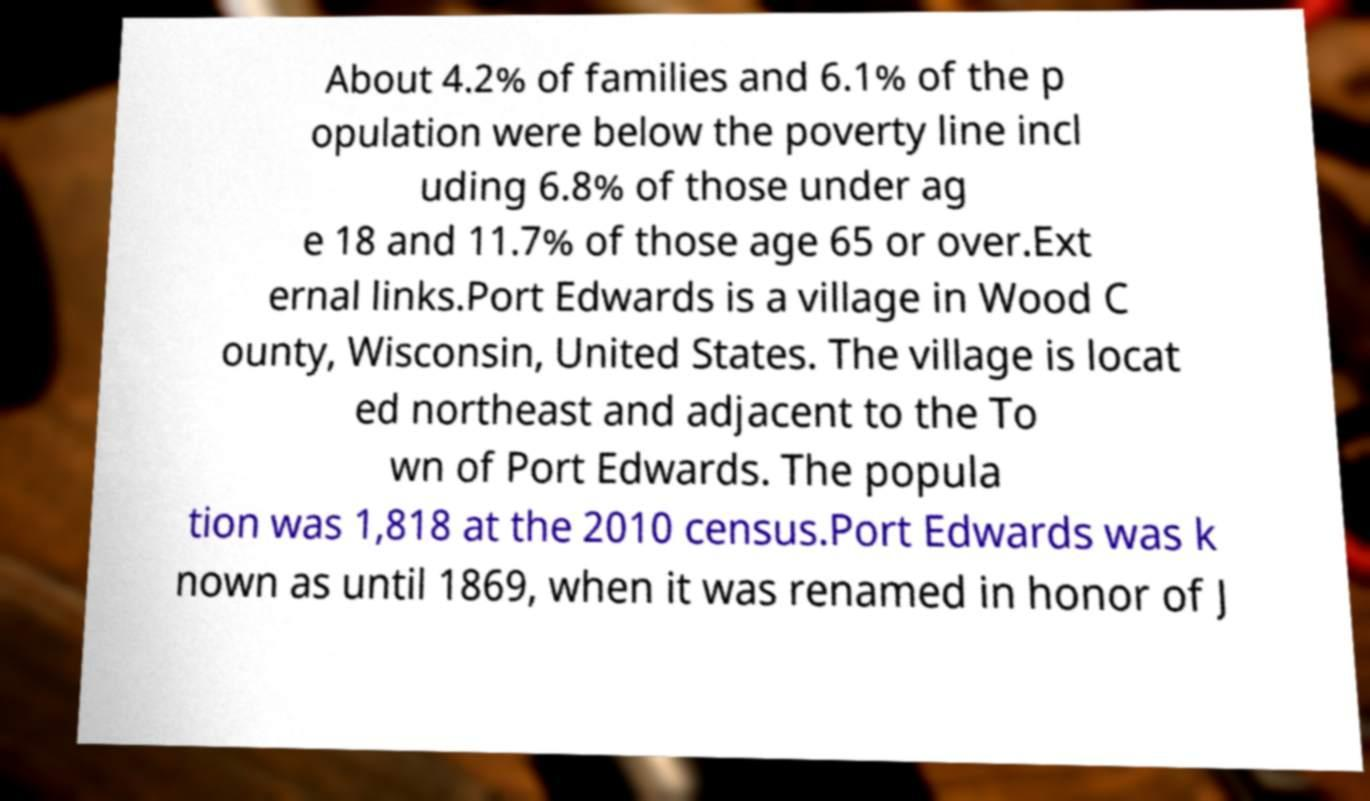Can you read and provide the text displayed in the image?This photo seems to have some interesting text. Can you extract and type it out for me? About 4.2% of families and 6.1% of the p opulation were below the poverty line incl uding 6.8% of those under ag e 18 and 11.7% of those age 65 or over.Ext ernal links.Port Edwards is a village in Wood C ounty, Wisconsin, United States. The village is locat ed northeast and adjacent to the To wn of Port Edwards. The popula tion was 1,818 at the 2010 census.Port Edwards was k nown as until 1869, when it was renamed in honor of J 